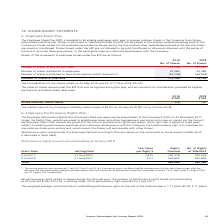According to Hansen Technologies's financial document, What is the Employee Performance Rights Plan? awards are made to eligible executives and other management personnel who have an impact on the Group’s performance. Rights Plan awards are granted in the form of performance rights over shares, which vest over a period of three years subject to meeting performance measures and continuous employment with the Company. Each performance right is to subscribe for one ordinary share upon vesting and, when issued, the shares will rank equally with other shares.. The document states: "’s AGM on 23 November 2017. Under the Rights Plan, awards are made to eligible executives and other management personnel who have an impact on the Gro..." Also, What was the total number of rights granted? According to the financial document, 885,968. The relevant text states: "Total 885,968 885,968..." Also, How many performance rights were issued and outstanding at 30 June 2018? According to the financial document, 355,316. The relevant text states: "2 Jul 2017 31 Aug 2020 3.815 355,316 355,316..." Also, can you calculate: What was the change in total fair value for rights granted on 2 July 2017 to 2 July 2018? Based on the calculation: (3.01 * 530,652) - (3.815 * 355,316) , the result is 241731.98. This is based on the information: "2 Jul 2017 31 Aug 2020 3.815 355,316 355,316 2 Jul 2018 31 Aug 2021 3.01 530,652 530,652 2 Jul 2017 31 Aug 2020 3.815 355,316 355,316 2 Jul 2018 31 Aug 2021 3.01 530,652 530,652..." The key data points involved are: 3.01, 3.815, 355,316. Also, can you calculate: What was the percentage change in number of rights granted? To answer this question, I need to perform calculations using the financial data. The calculation is: (530,652 - 355,316) / 355,316 , which equals 49.35 (percentage). This is based on the information: "2 Jul 2018 31 Aug 2021 3.01 530,652 530,652 2 Jul 2017 31 Aug 2020 3.815 355,316 355,316..." The key data points involved are: 355,316, 530,652. Also, can you calculate: What was the total fair value for all rights granted? Based on the calculation: (3.815 * 355,316) + (3.01 * 530,652) , the result is 2952793.06. This is based on the information: "2 Jul 2017 31 Aug 2020 3.815 355,316 355,316 2 Jul 2017 31 Aug 2020 3.815 355,316 355,316 2 Jul 2018 31 Aug 2021 3.01 530,652 530,652 2 Jul 2018 31 Aug 2021 3.01 530,652 530,652..." The key data points involved are: 3.01, 3.815, 355,316. 